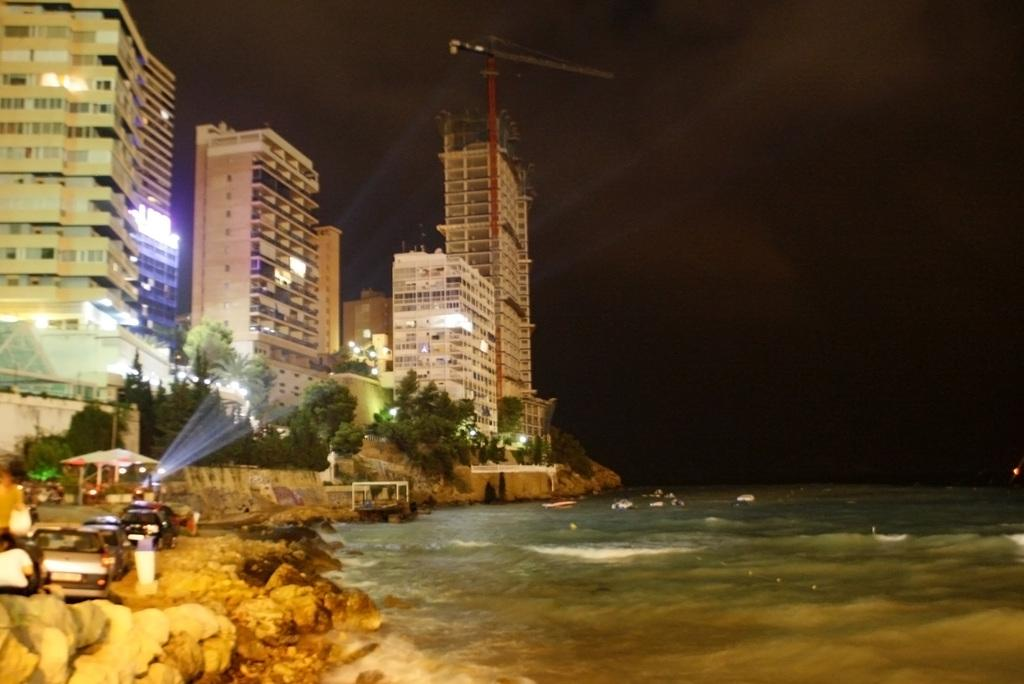What type of structures can be seen in the image? There are buildings in the image. What else is present in the image besides buildings? There are vehicles in the image. Can you describe the natural element visible in the image? There is water visible in the image. What type of seed can be seen growing near the buildings in the image? There is no seed visible in the image; the focus is on the buildings, vehicles, and water. 